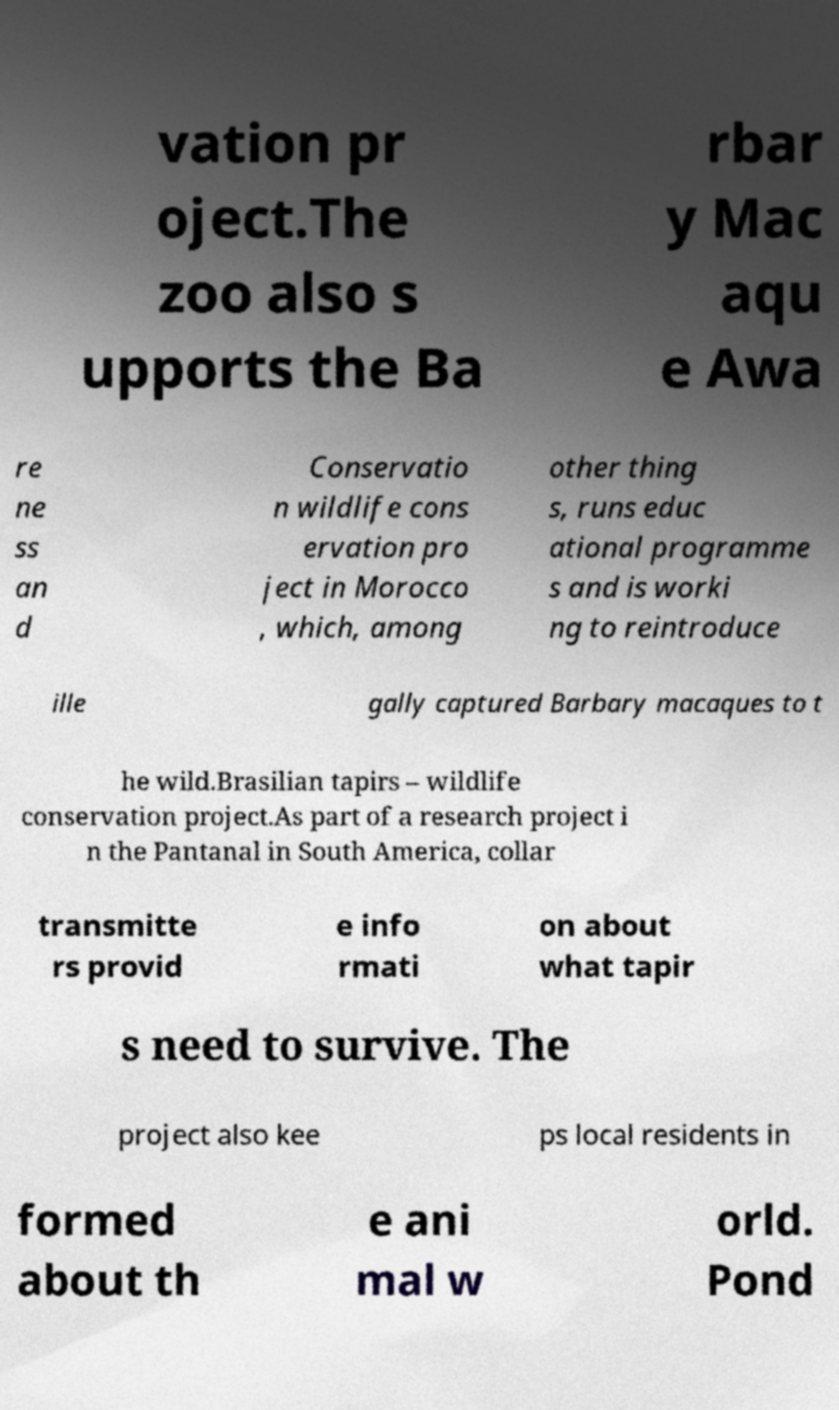Can you read and provide the text displayed in the image?This photo seems to have some interesting text. Can you extract and type it out for me? vation pr oject.The zoo also s upports the Ba rbar y Mac aqu e Awa re ne ss an d Conservatio n wildlife cons ervation pro ject in Morocco , which, among other thing s, runs educ ational programme s and is worki ng to reintroduce ille gally captured Barbary macaques to t he wild.Brasilian tapirs – wildlife conservation project.As part of a research project i n the Pantanal in South America, collar transmitte rs provid e info rmati on about what tapir s need to survive. The project also kee ps local residents in formed about th e ani mal w orld. Pond 